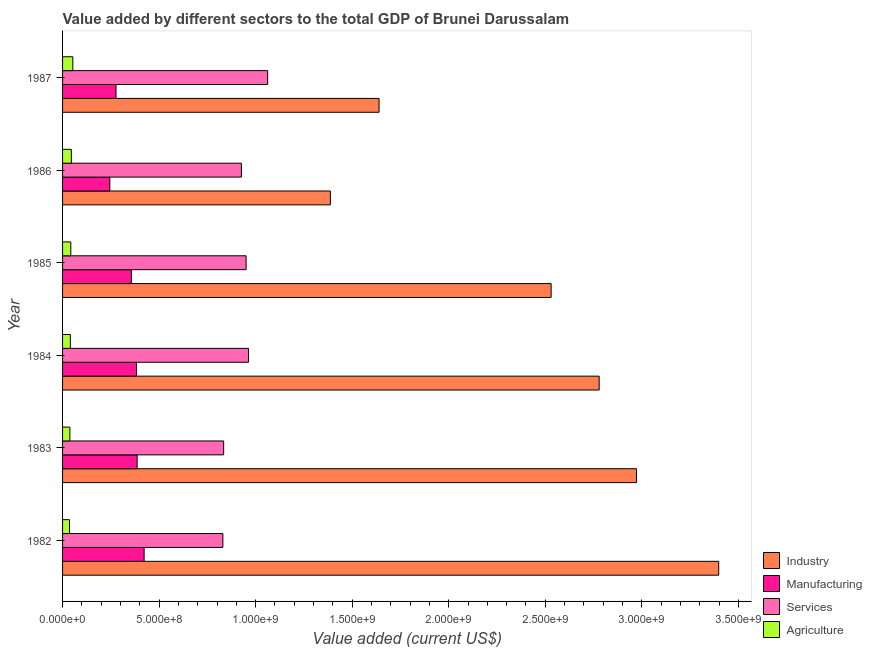How many groups of bars are there?
Your answer should be compact. 6. Are the number of bars on each tick of the Y-axis equal?
Offer a terse response. Yes. How many bars are there on the 6th tick from the top?
Keep it short and to the point. 4. What is the value added by agricultural sector in 1986?
Keep it short and to the point. 4.55e+07. Across all years, what is the maximum value added by industrial sector?
Ensure brevity in your answer.  3.40e+09. Across all years, what is the minimum value added by services sector?
Offer a terse response. 8.30e+08. In which year was the value added by manufacturing sector maximum?
Offer a very short reply. 1982. What is the total value added by agricultural sector in the graph?
Provide a succinct answer. 2.56e+08. What is the difference between the value added by industrial sector in 1983 and that in 1985?
Provide a short and direct response. 4.42e+08. What is the difference between the value added by industrial sector in 1982 and the value added by manufacturing sector in 1986?
Keep it short and to the point. 3.15e+09. What is the average value added by manufacturing sector per year?
Make the answer very short. 3.45e+08. In the year 1984, what is the difference between the value added by services sector and value added by industrial sector?
Make the answer very short. -1.82e+09. What is the ratio of the value added by agricultural sector in 1983 to that in 1984?
Your answer should be compact. 0.94. What is the difference between the highest and the second highest value added by agricultural sector?
Offer a very short reply. 7.71e+06. What is the difference between the highest and the lowest value added by agricultural sector?
Keep it short and to the point. 1.72e+07. What does the 3rd bar from the top in 1983 represents?
Your answer should be compact. Manufacturing. What does the 2nd bar from the bottom in 1984 represents?
Offer a terse response. Manufacturing. Are all the bars in the graph horizontal?
Offer a terse response. Yes. What is the difference between two consecutive major ticks on the X-axis?
Make the answer very short. 5.00e+08. What is the title of the graph?
Make the answer very short. Value added by different sectors to the total GDP of Brunei Darussalam. What is the label or title of the X-axis?
Make the answer very short. Value added (current US$). What is the label or title of the Y-axis?
Your response must be concise. Year. What is the Value added (current US$) in Industry in 1982?
Keep it short and to the point. 3.40e+09. What is the Value added (current US$) in Manufacturing in 1982?
Your answer should be very brief. 4.22e+08. What is the Value added (current US$) of Services in 1982?
Offer a terse response. 8.30e+08. What is the Value added (current US$) in Agriculture in 1982?
Offer a terse response. 3.60e+07. What is the Value added (current US$) of Industry in 1983?
Your answer should be compact. 2.97e+09. What is the Value added (current US$) in Manufacturing in 1983?
Keep it short and to the point. 3.86e+08. What is the Value added (current US$) of Services in 1983?
Your answer should be compact. 8.34e+08. What is the Value added (current US$) of Agriculture in 1983?
Your answer should be compact. 3.79e+07. What is the Value added (current US$) of Industry in 1984?
Make the answer very short. 2.78e+09. What is the Value added (current US$) of Manufacturing in 1984?
Provide a short and direct response. 3.83e+08. What is the Value added (current US$) in Services in 1984?
Provide a succinct answer. 9.63e+08. What is the Value added (current US$) of Agriculture in 1984?
Provide a short and direct response. 4.03e+07. What is the Value added (current US$) of Industry in 1985?
Your response must be concise. 2.53e+09. What is the Value added (current US$) in Manufacturing in 1985?
Ensure brevity in your answer.  3.56e+08. What is the Value added (current US$) of Services in 1985?
Provide a succinct answer. 9.51e+08. What is the Value added (current US$) in Agriculture in 1985?
Make the answer very short. 4.27e+07. What is the Value added (current US$) in Industry in 1986?
Your response must be concise. 1.39e+09. What is the Value added (current US$) of Manufacturing in 1986?
Offer a terse response. 2.45e+08. What is the Value added (current US$) of Services in 1986?
Provide a succinct answer. 9.26e+08. What is the Value added (current US$) in Agriculture in 1986?
Keep it short and to the point. 4.55e+07. What is the Value added (current US$) of Industry in 1987?
Give a very brief answer. 1.64e+09. What is the Value added (current US$) in Manufacturing in 1987?
Your answer should be compact. 2.77e+08. What is the Value added (current US$) of Services in 1987?
Offer a very short reply. 1.06e+09. What is the Value added (current US$) in Agriculture in 1987?
Offer a terse response. 5.32e+07. Across all years, what is the maximum Value added (current US$) of Industry?
Give a very brief answer. 3.40e+09. Across all years, what is the maximum Value added (current US$) in Manufacturing?
Provide a short and direct response. 4.22e+08. Across all years, what is the maximum Value added (current US$) in Services?
Keep it short and to the point. 1.06e+09. Across all years, what is the maximum Value added (current US$) in Agriculture?
Offer a terse response. 5.32e+07. Across all years, what is the minimum Value added (current US$) of Industry?
Make the answer very short. 1.39e+09. Across all years, what is the minimum Value added (current US$) of Manufacturing?
Provide a short and direct response. 2.45e+08. Across all years, what is the minimum Value added (current US$) in Services?
Offer a very short reply. 8.30e+08. Across all years, what is the minimum Value added (current US$) in Agriculture?
Provide a short and direct response. 3.60e+07. What is the total Value added (current US$) in Industry in the graph?
Offer a terse response. 1.47e+1. What is the total Value added (current US$) of Manufacturing in the graph?
Your answer should be compact. 2.07e+09. What is the total Value added (current US$) of Services in the graph?
Offer a terse response. 5.57e+09. What is the total Value added (current US$) in Agriculture in the graph?
Provide a short and direct response. 2.56e+08. What is the difference between the Value added (current US$) in Industry in 1982 and that in 1983?
Make the answer very short. 4.26e+08. What is the difference between the Value added (current US$) in Manufacturing in 1982 and that in 1983?
Your response must be concise. 3.62e+07. What is the difference between the Value added (current US$) of Services in 1982 and that in 1983?
Your answer should be very brief. -4.17e+06. What is the difference between the Value added (current US$) in Agriculture in 1982 and that in 1983?
Your answer should be very brief. -1.88e+06. What is the difference between the Value added (current US$) of Industry in 1982 and that in 1984?
Provide a short and direct response. 6.19e+08. What is the difference between the Value added (current US$) in Manufacturing in 1982 and that in 1984?
Your answer should be very brief. 3.94e+07. What is the difference between the Value added (current US$) in Services in 1982 and that in 1984?
Provide a succinct answer. -1.33e+08. What is the difference between the Value added (current US$) in Agriculture in 1982 and that in 1984?
Your answer should be compact. -4.34e+06. What is the difference between the Value added (current US$) in Industry in 1982 and that in 1985?
Ensure brevity in your answer.  8.68e+08. What is the difference between the Value added (current US$) in Manufacturing in 1982 and that in 1985?
Offer a terse response. 6.61e+07. What is the difference between the Value added (current US$) in Services in 1982 and that in 1985?
Make the answer very short. -1.20e+08. What is the difference between the Value added (current US$) of Agriculture in 1982 and that in 1985?
Offer a terse response. -6.74e+06. What is the difference between the Value added (current US$) of Industry in 1982 and that in 1986?
Provide a succinct answer. 2.01e+09. What is the difference between the Value added (current US$) in Manufacturing in 1982 and that in 1986?
Provide a succinct answer. 1.78e+08. What is the difference between the Value added (current US$) in Services in 1982 and that in 1986?
Your answer should be very brief. -9.60e+07. What is the difference between the Value added (current US$) of Agriculture in 1982 and that in 1986?
Ensure brevity in your answer.  -9.49e+06. What is the difference between the Value added (current US$) of Industry in 1982 and that in 1987?
Your answer should be compact. 1.76e+09. What is the difference between the Value added (current US$) in Manufacturing in 1982 and that in 1987?
Your response must be concise. 1.46e+08. What is the difference between the Value added (current US$) of Services in 1982 and that in 1987?
Your answer should be very brief. -2.32e+08. What is the difference between the Value added (current US$) of Agriculture in 1982 and that in 1987?
Give a very brief answer. -1.72e+07. What is the difference between the Value added (current US$) in Industry in 1983 and that in 1984?
Provide a succinct answer. 1.93e+08. What is the difference between the Value added (current US$) in Manufacturing in 1983 and that in 1984?
Give a very brief answer. 3.17e+06. What is the difference between the Value added (current US$) in Services in 1983 and that in 1984?
Make the answer very short. -1.29e+08. What is the difference between the Value added (current US$) of Agriculture in 1983 and that in 1984?
Ensure brevity in your answer.  -2.46e+06. What is the difference between the Value added (current US$) of Industry in 1983 and that in 1985?
Make the answer very short. 4.42e+08. What is the difference between the Value added (current US$) in Manufacturing in 1983 and that in 1985?
Make the answer very short. 2.98e+07. What is the difference between the Value added (current US$) in Services in 1983 and that in 1985?
Provide a short and direct response. -1.16e+08. What is the difference between the Value added (current US$) in Agriculture in 1983 and that in 1985?
Your answer should be compact. -4.86e+06. What is the difference between the Value added (current US$) of Industry in 1983 and that in 1986?
Ensure brevity in your answer.  1.59e+09. What is the difference between the Value added (current US$) of Manufacturing in 1983 and that in 1986?
Your answer should be compact. 1.41e+08. What is the difference between the Value added (current US$) of Services in 1983 and that in 1986?
Your answer should be very brief. -9.18e+07. What is the difference between the Value added (current US$) of Agriculture in 1983 and that in 1986?
Make the answer very short. -7.61e+06. What is the difference between the Value added (current US$) of Industry in 1983 and that in 1987?
Give a very brief answer. 1.33e+09. What is the difference between the Value added (current US$) in Manufacturing in 1983 and that in 1987?
Offer a terse response. 1.09e+08. What is the difference between the Value added (current US$) in Services in 1983 and that in 1987?
Your response must be concise. -2.28e+08. What is the difference between the Value added (current US$) of Agriculture in 1983 and that in 1987?
Provide a succinct answer. -1.53e+07. What is the difference between the Value added (current US$) in Industry in 1984 and that in 1985?
Make the answer very short. 2.49e+08. What is the difference between the Value added (current US$) in Manufacturing in 1984 and that in 1985?
Offer a very short reply. 2.67e+07. What is the difference between the Value added (current US$) of Services in 1984 and that in 1985?
Keep it short and to the point. 1.26e+07. What is the difference between the Value added (current US$) of Agriculture in 1984 and that in 1985?
Provide a short and direct response. -2.41e+06. What is the difference between the Value added (current US$) of Industry in 1984 and that in 1986?
Make the answer very short. 1.39e+09. What is the difference between the Value added (current US$) in Manufacturing in 1984 and that in 1986?
Keep it short and to the point. 1.38e+08. What is the difference between the Value added (current US$) in Services in 1984 and that in 1986?
Give a very brief answer. 3.70e+07. What is the difference between the Value added (current US$) of Agriculture in 1984 and that in 1986?
Provide a succinct answer. -5.15e+06. What is the difference between the Value added (current US$) of Industry in 1984 and that in 1987?
Keep it short and to the point. 1.14e+09. What is the difference between the Value added (current US$) in Manufacturing in 1984 and that in 1987?
Keep it short and to the point. 1.06e+08. What is the difference between the Value added (current US$) of Services in 1984 and that in 1987?
Make the answer very short. -9.90e+07. What is the difference between the Value added (current US$) of Agriculture in 1984 and that in 1987?
Your answer should be very brief. -1.29e+07. What is the difference between the Value added (current US$) in Industry in 1985 and that in 1986?
Provide a short and direct response. 1.14e+09. What is the difference between the Value added (current US$) of Manufacturing in 1985 and that in 1986?
Your answer should be very brief. 1.12e+08. What is the difference between the Value added (current US$) in Services in 1985 and that in 1986?
Keep it short and to the point. 2.44e+07. What is the difference between the Value added (current US$) in Agriculture in 1985 and that in 1986?
Provide a short and direct response. -2.74e+06. What is the difference between the Value added (current US$) in Industry in 1985 and that in 1987?
Ensure brevity in your answer.  8.91e+08. What is the difference between the Value added (current US$) of Manufacturing in 1985 and that in 1987?
Keep it short and to the point. 7.95e+07. What is the difference between the Value added (current US$) in Services in 1985 and that in 1987?
Ensure brevity in your answer.  -1.12e+08. What is the difference between the Value added (current US$) of Agriculture in 1985 and that in 1987?
Make the answer very short. -1.05e+07. What is the difference between the Value added (current US$) of Industry in 1986 and that in 1987?
Make the answer very short. -2.52e+08. What is the difference between the Value added (current US$) in Manufacturing in 1986 and that in 1987?
Provide a short and direct response. -3.20e+07. What is the difference between the Value added (current US$) of Services in 1986 and that in 1987?
Your response must be concise. -1.36e+08. What is the difference between the Value added (current US$) in Agriculture in 1986 and that in 1987?
Make the answer very short. -7.71e+06. What is the difference between the Value added (current US$) in Industry in 1982 and the Value added (current US$) in Manufacturing in 1983?
Keep it short and to the point. 3.01e+09. What is the difference between the Value added (current US$) of Industry in 1982 and the Value added (current US$) of Services in 1983?
Provide a short and direct response. 2.56e+09. What is the difference between the Value added (current US$) of Industry in 1982 and the Value added (current US$) of Agriculture in 1983?
Provide a succinct answer. 3.36e+09. What is the difference between the Value added (current US$) in Manufacturing in 1982 and the Value added (current US$) in Services in 1983?
Provide a succinct answer. -4.12e+08. What is the difference between the Value added (current US$) in Manufacturing in 1982 and the Value added (current US$) in Agriculture in 1983?
Provide a short and direct response. 3.85e+08. What is the difference between the Value added (current US$) in Services in 1982 and the Value added (current US$) in Agriculture in 1983?
Make the answer very short. 7.92e+08. What is the difference between the Value added (current US$) in Industry in 1982 and the Value added (current US$) in Manufacturing in 1984?
Make the answer very short. 3.02e+09. What is the difference between the Value added (current US$) in Industry in 1982 and the Value added (current US$) in Services in 1984?
Make the answer very short. 2.43e+09. What is the difference between the Value added (current US$) in Industry in 1982 and the Value added (current US$) in Agriculture in 1984?
Offer a terse response. 3.36e+09. What is the difference between the Value added (current US$) in Manufacturing in 1982 and the Value added (current US$) in Services in 1984?
Your answer should be very brief. -5.41e+08. What is the difference between the Value added (current US$) in Manufacturing in 1982 and the Value added (current US$) in Agriculture in 1984?
Provide a short and direct response. 3.82e+08. What is the difference between the Value added (current US$) of Services in 1982 and the Value added (current US$) of Agriculture in 1984?
Your answer should be compact. 7.90e+08. What is the difference between the Value added (current US$) of Industry in 1982 and the Value added (current US$) of Manufacturing in 1985?
Your answer should be very brief. 3.04e+09. What is the difference between the Value added (current US$) of Industry in 1982 and the Value added (current US$) of Services in 1985?
Make the answer very short. 2.45e+09. What is the difference between the Value added (current US$) of Industry in 1982 and the Value added (current US$) of Agriculture in 1985?
Offer a very short reply. 3.36e+09. What is the difference between the Value added (current US$) of Manufacturing in 1982 and the Value added (current US$) of Services in 1985?
Your answer should be compact. -5.28e+08. What is the difference between the Value added (current US$) in Manufacturing in 1982 and the Value added (current US$) in Agriculture in 1985?
Offer a very short reply. 3.80e+08. What is the difference between the Value added (current US$) in Services in 1982 and the Value added (current US$) in Agriculture in 1985?
Keep it short and to the point. 7.87e+08. What is the difference between the Value added (current US$) in Industry in 1982 and the Value added (current US$) in Manufacturing in 1986?
Give a very brief answer. 3.15e+09. What is the difference between the Value added (current US$) in Industry in 1982 and the Value added (current US$) in Services in 1986?
Your answer should be very brief. 2.47e+09. What is the difference between the Value added (current US$) in Industry in 1982 and the Value added (current US$) in Agriculture in 1986?
Give a very brief answer. 3.35e+09. What is the difference between the Value added (current US$) of Manufacturing in 1982 and the Value added (current US$) of Services in 1986?
Give a very brief answer. -5.04e+08. What is the difference between the Value added (current US$) of Manufacturing in 1982 and the Value added (current US$) of Agriculture in 1986?
Provide a succinct answer. 3.77e+08. What is the difference between the Value added (current US$) of Services in 1982 and the Value added (current US$) of Agriculture in 1986?
Make the answer very short. 7.85e+08. What is the difference between the Value added (current US$) of Industry in 1982 and the Value added (current US$) of Manufacturing in 1987?
Offer a terse response. 3.12e+09. What is the difference between the Value added (current US$) in Industry in 1982 and the Value added (current US$) in Services in 1987?
Your answer should be very brief. 2.34e+09. What is the difference between the Value added (current US$) of Industry in 1982 and the Value added (current US$) of Agriculture in 1987?
Provide a short and direct response. 3.34e+09. What is the difference between the Value added (current US$) in Manufacturing in 1982 and the Value added (current US$) in Services in 1987?
Make the answer very short. -6.40e+08. What is the difference between the Value added (current US$) of Manufacturing in 1982 and the Value added (current US$) of Agriculture in 1987?
Your response must be concise. 3.69e+08. What is the difference between the Value added (current US$) of Services in 1982 and the Value added (current US$) of Agriculture in 1987?
Give a very brief answer. 7.77e+08. What is the difference between the Value added (current US$) in Industry in 1983 and the Value added (current US$) in Manufacturing in 1984?
Make the answer very short. 2.59e+09. What is the difference between the Value added (current US$) of Industry in 1983 and the Value added (current US$) of Services in 1984?
Your answer should be compact. 2.01e+09. What is the difference between the Value added (current US$) of Industry in 1983 and the Value added (current US$) of Agriculture in 1984?
Ensure brevity in your answer.  2.93e+09. What is the difference between the Value added (current US$) in Manufacturing in 1983 and the Value added (current US$) in Services in 1984?
Give a very brief answer. -5.77e+08. What is the difference between the Value added (current US$) of Manufacturing in 1983 and the Value added (current US$) of Agriculture in 1984?
Your response must be concise. 3.46e+08. What is the difference between the Value added (current US$) of Services in 1983 and the Value added (current US$) of Agriculture in 1984?
Make the answer very short. 7.94e+08. What is the difference between the Value added (current US$) in Industry in 1983 and the Value added (current US$) in Manufacturing in 1985?
Offer a terse response. 2.62e+09. What is the difference between the Value added (current US$) of Industry in 1983 and the Value added (current US$) of Services in 1985?
Give a very brief answer. 2.02e+09. What is the difference between the Value added (current US$) in Industry in 1983 and the Value added (current US$) in Agriculture in 1985?
Provide a short and direct response. 2.93e+09. What is the difference between the Value added (current US$) in Manufacturing in 1983 and the Value added (current US$) in Services in 1985?
Provide a succinct answer. -5.64e+08. What is the difference between the Value added (current US$) in Manufacturing in 1983 and the Value added (current US$) in Agriculture in 1985?
Your answer should be very brief. 3.43e+08. What is the difference between the Value added (current US$) in Services in 1983 and the Value added (current US$) in Agriculture in 1985?
Make the answer very short. 7.92e+08. What is the difference between the Value added (current US$) in Industry in 1983 and the Value added (current US$) in Manufacturing in 1986?
Provide a short and direct response. 2.73e+09. What is the difference between the Value added (current US$) in Industry in 1983 and the Value added (current US$) in Services in 1986?
Offer a very short reply. 2.05e+09. What is the difference between the Value added (current US$) of Industry in 1983 and the Value added (current US$) of Agriculture in 1986?
Make the answer very short. 2.93e+09. What is the difference between the Value added (current US$) of Manufacturing in 1983 and the Value added (current US$) of Services in 1986?
Give a very brief answer. -5.40e+08. What is the difference between the Value added (current US$) of Manufacturing in 1983 and the Value added (current US$) of Agriculture in 1986?
Your answer should be very brief. 3.41e+08. What is the difference between the Value added (current US$) in Services in 1983 and the Value added (current US$) in Agriculture in 1986?
Provide a short and direct response. 7.89e+08. What is the difference between the Value added (current US$) of Industry in 1983 and the Value added (current US$) of Manufacturing in 1987?
Offer a very short reply. 2.70e+09. What is the difference between the Value added (current US$) of Industry in 1983 and the Value added (current US$) of Services in 1987?
Offer a terse response. 1.91e+09. What is the difference between the Value added (current US$) of Industry in 1983 and the Value added (current US$) of Agriculture in 1987?
Provide a succinct answer. 2.92e+09. What is the difference between the Value added (current US$) of Manufacturing in 1983 and the Value added (current US$) of Services in 1987?
Your answer should be compact. -6.76e+08. What is the difference between the Value added (current US$) in Manufacturing in 1983 and the Value added (current US$) in Agriculture in 1987?
Make the answer very short. 3.33e+08. What is the difference between the Value added (current US$) in Services in 1983 and the Value added (current US$) in Agriculture in 1987?
Offer a very short reply. 7.81e+08. What is the difference between the Value added (current US$) of Industry in 1984 and the Value added (current US$) of Manufacturing in 1985?
Provide a short and direct response. 2.42e+09. What is the difference between the Value added (current US$) in Industry in 1984 and the Value added (current US$) in Services in 1985?
Give a very brief answer. 1.83e+09. What is the difference between the Value added (current US$) of Industry in 1984 and the Value added (current US$) of Agriculture in 1985?
Provide a succinct answer. 2.74e+09. What is the difference between the Value added (current US$) of Manufacturing in 1984 and the Value added (current US$) of Services in 1985?
Give a very brief answer. -5.68e+08. What is the difference between the Value added (current US$) in Manufacturing in 1984 and the Value added (current US$) in Agriculture in 1985?
Keep it short and to the point. 3.40e+08. What is the difference between the Value added (current US$) of Services in 1984 and the Value added (current US$) of Agriculture in 1985?
Your answer should be very brief. 9.20e+08. What is the difference between the Value added (current US$) in Industry in 1984 and the Value added (current US$) in Manufacturing in 1986?
Ensure brevity in your answer.  2.53e+09. What is the difference between the Value added (current US$) in Industry in 1984 and the Value added (current US$) in Services in 1986?
Ensure brevity in your answer.  1.85e+09. What is the difference between the Value added (current US$) in Industry in 1984 and the Value added (current US$) in Agriculture in 1986?
Give a very brief answer. 2.73e+09. What is the difference between the Value added (current US$) of Manufacturing in 1984 and the Value added (current US$) of Services in 1986?
Your answer should be very brief. -5.43e+08. What is the difference between the Value added (current US$) in Manufacturing in 1984 and the Value added (current US$) in Agriculture in 1986?
Provide a succinct answer. 3.38e+08. What is the difference between the Value added (current US$) of Services in 1984 and the Value added (current US$) of Agriculture in 1986?
Provide a succinct answer. 9.18e+08. What is the difference between the Value added (current US$) of Industry in 1984 and the Value added (current US$) of Manufacturing in 1987?
Your answer should be very brief. 2.50e+09. What is the difference between the Value added (current US$) in Industry in 1984 and the Value added (current US$) in Services in 1987?
Your answer should be very brief. 1.72e+09. What is the difference between the Value added (current US$) in Industry in 1984 and the Value added (current US$) in Agriculture in 1987?
Provide a short and direct response. 2.73e+09. What is the difference between the Value added (current US$) in Manufacturing in 1984 and the Value added (current US$) in Services in 1987?
Ensure brevity in your answer.  -6.79e+08. What is the difference between the Value added (current US$) of Manufacturing in 1984 and the Value added (current US$) of Agriculture in 1987?
Provide a short and direct response. 3.30e+08. What is the difference between the Value added (current US$) in Services in 1984 and the Value added (current US$) in Agriculture in 1987?
Your response must be concise. 9.10e+08. What is the difference between the Value added (current US$) in Industry in 1985 and the Value added (current US$) in Manufacturing in 1986?
Give a very brief answer. 2.29e+09. What is the difference between the Value added (current US$) in Industry in 1985 and the Value added (current US$) in Services in 1986?
Make the answer very short. 1.60e+09. What is the difference between the Value added (current US$) in Industry in 1985 and the Value added (current US$) in Agriculture in 1986?
Provide a succinct answer. 2.48e+09. What is the difference between the Value added (current US$) of Manufacturing in 1985 and the Value added (current US$) of Services in 1986?
Your answer should be very brief. -5.70e+08. What is the difference between the Value added (current US$) in Manufacturing in 1985 and the Value added (current US$) in Agriculture in 1986?
Provide a short and direct response. 3.11e+08. What is the difference between the Value added (current US$) of Services in 1985 and the Value added (current US$) of Agriculture in 1986?
Ensure brevity in your answer.  9.05e+08. What is the difference between the Value added (current US$) in Industry in 1985 and the Value added (current US$) in Manufacturing in 1987?
Keep it short and to the point. 2.25e+09. What is the difference between the Value added (current US$) of Industry in 1985 and the Value added (current US$) of Services in 1987?
Offer a very short reply. 1.47e+09. What is the difference between the Value added (current US$) in Industry in 1985 and the Value added (current US$) in Agriculture in 1987?
Your response must be concise. 2.48e+09. What is the difference between the Value added (current US$) in Manufacturing in 1985 and the Value added (current US$) in Services in 1987?
Your response must be concise. -7.06e+08. What is the difference between the Value added (current US$) in Manufacturing in 1985 and the Value added (current US$) in Agriculture in 1987?
Offer a terse response. 3.03e+08. What is the difference between the Value added (current US$) of Services in 1985 and the Value added (current US$) of Agriculture in 1987?
Provide a short and direct response. 8.97e+08. What is the difference between the Value added (current US$) in Industry in 1986 and the Value added (current US$) in Manufacturing in 1987?
Your answer should be compact. 1.11e+09. What is the difference between the Value added (current US$) of Industry in 1986 and the Value added (current US$) of Services in 1987?
Your answer should be very brief. 3.25e+08. What is the difference between the Value added (current US$) in Industry in 1986 and the Value added (current US$) in Agriculture in 1987?
Your response must be concise. 1.33e+09. What is the difference between the Value added (current US$) of Manufacturing in 1986 and the Value added (current US$) of Services in 1987?
Offer a terse response. -8.17e+08. What is the difference between the Value added (current US$) in Manufacturing in 1986 and the Value added (current US$) in Agriculture in 1987?
Offer a terse response. 1.92e+08. What is the difference between the Value added (current US$) of Services in 1986 and the Value added (current US$) of Agriculture in 1987?
Offer a very short reply. 8.73e+08. What is the average Value added (current US$) in Industry per year?
Your answer should be very brief. 2.45e+09. What is the average Value added (current US$) in Manufacturing per year?
Your response must be concise. 3.45e+08. What is the average Value added (current US$) of Services per year?
Make the answer very short. 9.28e+08. What is the average Value added (current US$) of Agriculture per year?
Give a very brief answer. 4.26e+07. In the year 1982, what is the difference between the Value added (current US$) of Industry and Value added (current US$) of Manufacturing?
Keep it short and to the point. 2.98e+09. In the year 1982, what is the difference between the Value added (current US$) of Industry and Value added (current US$) of Services?
Give a very brief answer. 2.57e+09. In the year 1982, what is the difference between the Value added (current US$) of Industry and Value added (current US$) of Agriculture?
Your answer should be compact. 3.36e+09. In the year 1982, what is the difference between the Value added (current US$) of Manufacturing and Value added (current US$) of Services?
Provide a short and direct response. -4.08e+08. In the year 1982, what is the difference between the Value added (current US$) in Manufacturing and Value added (current US$) in Agriculture?
Your answer should be very brief. 3.86e+08. In the year 1982, what is the difference between the Value added (current US$) of Services and Value added (current US$) of Agriculture?
Keep it short and to the point. 7.94e+08. In the year 1983, what is the difference between the Value added (current US$) in Industry and Value added (current US$) in Manufacturing?
Offer a terse response. 2.59e+09. In the year 1983, what is the difference between the Value added (current US$) in Industry and Value added (current US$) in Services?
Offer a terse response. 2.14e+09. In the year 1983, what is the difference between the Value added (current US$) in Industry and Value added (current US$) in Agriculture?
Make the answer very short. 2.93e+09. In the year 1983, what is the difference between the Value added (current US$) of Manufacturing and Value added (current US$) of Services?
Offer a very short reply. -4.48e+08. In the year 1983, what is the difference between the Value added (current US$) in Manufacturing and Value added (current US$) in Agriculture?
Your answer should be compact. 3.48e+08. In the year 1983, what is the difference between the Value added (current US$) of Services and Value added (current US$) of Agriculture?
Offer a very short reply. 7.96e+08. In the year 1984, what is the difference between the Value added (current US$) in Industry and Value added (current US$) in Manufacturing?
Your answer should be very brief. 2.40e+09. In the year 1984, what is the difference between the Value added (current US$) of Industry and Value added (current US$) of Services?
Offer a very short reply. 1.82e+09. In the year 1984, what is the difference between the Value added (current US$) of Industry and Value added (current US$) of Agriculture?
Give a very brief answer. 2.74e+09. In the year 1984, what is the difference between the Value added (current US$) in Manufacturing and Value added (current US$) in Services?
Your answer should be very brief. -5.80e+08. In the year 1984, what is the difference between the Value added (current US$) of Manufacturing and Value added (current US$) of Agriculture?
Make the answer very short. 3.43e+08. In the year 1984, what is the difference between the Value added (current US$) of Services and Value added (current US$) of Agriculture?
Your response must be concise. 9.23e+08. In the year 1985, what is the difference between the Value added (current US$) of Industry and Value added (current US$) of Manufacturing?
Your answer should be very brief. 2.17e+09. In the year 1985, what is the difference between the Value added (current US$) in Industry and Value added (current US$) in Services?
Make the answer very short. 1.58e+09. In the year 1985, what is the difference between the Value added (current US$) of Industry and Value added (current US$) of Agriculture?
Offer a terse response. 2.49e+09. In the year 1985, what is the difference between the Value added (current US$) in Manufacturing and Value added (current US$) in Services?
Your response must be concise. -5.94e+08. In the year 1985, what is the difference between the Value added (current US$) of Manufacturing and Value added (current US$) of Agriculture?
Provide a succinct answer. 3.14e+08. In the year 1985, what is the difference between the Value added (current US$) of Services and Value added (current US$) of Agriculture?
Provide a short and direct response. 9.08e+08. In the year 1986, what is the difference between the Value added (current US$) in Industry and Value added (current US$) in Manufacturing?
Your answer should be compact. 1.14e+09. In the year 1986, what is the difference between the Value added (current US$) in Industry and Value added (current US$) in Services?
Make the answer very short. 4.61e+08. In the year 1986, what is the difference between the Value added (current US$) of Industry and Value added (current US$) of Agriculture?
Keep it short and to the point. 1.34e+09. In the year 1986, what is the difference between the Value added (current US$) of Manufacturing and Value added (current US$) of Services?
Ensure brevity in your answer.  -6.81e+08. In the year 1986, what is the difference between the Value added (current US$) of Manufacturing and Value added (current US$) of Agriculture?
Your answer should be very brief. 1.99e+08. In the year 1986, what is the difference between the Value added (current US$) of Services and Value added (current US$) of Agriculture?
Provide a succinct answer. 8.81e+08. In the year 1987, what is the difference between the Value added (current US$) of Industry and Value added (current US$) of Manufacturing?
Your answer should be compact. 1.36e+09. In the year 1987, what is the difference between the Value added (current US$) in Industry and Value added (current US$) in Services?
Ensure brevity in your answer.  5.77e+08. In the year 1987, what is the difference between the Value added (current US$) in Industry and Value added (current US$) in Agriculture?
Ensure brevity in your answer.  1.59e+09. In the year 1987, what is the difference between the Value added (current US$) in Manufacturing and Value added (current US$) in Services?
Offer a terse response. -7.85e+08. In the year 1987, what is the difference between the Value added (current US$) of Manufacturing and Value added (current US$) of Agriculture?
Offer a very short reply. 2.24e+08. In the year 1987, what is the difference between the Value added (current US$) of Services and Value added (current US$) of Agriculture?
Ensure brevity in your answer.  1.01e+09. What is the ratio of the Value added (current US$) of Industry in 1982 to that in 1983?
Give a very brief answer. 1.14. What is the ratio of the Value added (current US$) of Manufacturing in 1982 to that in 1983?
Offer a very short reply. 1.09. What is the ratio of the Value added (current US$) in Agriculture in 1982 to that in 1983?
Make the answer very short. 0.95. What is the ratio of the Value added (current US$) of Industry in 1982 to that in 1984?
Keep it short and to the point. 1.22. What is the ratio of the Value added (current US$) of Manufacturing in 1982 to that in 1984?
Offer a very short reply. 1.1. What is the ratio of the Value added (current US$) of Services in 1982 to that in 1984?
Give a very brief answer. 0.86. What is the ratio of the Value added (current US$) of Agriculture in 1982 to that in 1984?
Provide a short and direct response. 0.89. What is the ratio of the Value added (current US$) in Industry in 1982 to that in 1985?
Provide a succinct answer. 1.34. What is the ratio of the Value added (current US$) of Manufacturing in 1982 to that in 1985?
Keep it short and to the point. 1.19. What is the ratio of the Value added (current US$) of Services in 1982 to that in 1985?
Offer a very short reply. 0.87. What is the ratio of the Value added (current US$) of Agriculture in 1982 to that in 1985?
Give a very brief answer. 0.84. What is the ratio of the Value added (current US$) of Industry in 1982 to that in 1986?
Keep it short and to the point. 2.45. What is the ratio of the Value added (current US$) in Manufacturing in 1982 to that in 1986?
Your answer should be very brief. 1.73. What is the ratio of the Value added (current US$) in Services in 1982 to that in 1986?
Your response must be concise. 0.9. What is the ratio of the Value added (current US$) in Agriculture in 1982 to that in 1986?
Offer a very short reply. 0.79. What is the ratio of the Value added (current US$) in Industry in 1982 to that in 1987?
Make the answer very short. 2.07. What is the ratio of the Value added (current US$) in Manufacturing in 1982 to that in 1987?
Offer a very short reply. 1.53. What is the ratio of the Value added (current US$) of Services in 1982 to that in 1987?
Keep it short and to the point. 0.78. What is the ratio of the Value added (current US$) of Agriculture in 1982 to that in 1987?
Offer a terse response. 0.68. What is the ratio of the Value added (current US$) in Industry in 1983 to that in 1984?
Your answer should be compact. 1.07. What is the ratio of the Value added (current US$) in Manufacturing in 1983 to that in 1984?
Your answer should be compact. 1.01. What is the ratio of the Value added (current US$) in Services in 1983 to that in 1984?
Provide a short and direct response. 0.87. What is the ratio of the Value added (current US$) in Agriculture in 1983 to that in 1984?
Give a very brief answer. 0.94. What is the ratio of the Value added (current US$) in Industry in 1983 to that in 1985?
Provide a succinct answer. 1.17. What is the ratio of the Value added (current US$) of Manufacturing in 1983 to that in 1985?
Your answer should be very brief. 1.08. What is the ratio of the Value added (current US$) of Services in 1983 to that in 1985?
Offer a terse response. 0.88. What is the ratio of the Value added (current US$) in Agriculture in 1983 to that in 1985?
Your answer should be compact. 0.89. What is the ratio of the Value added (current US$) of Industry in 1983 to that in 1986?
Offer a terse response. 2.14. What is the ratio of the Value added (current US$) in Manufacturing in 1983 to that in 1986?
Your response must be concise. 1.58. What is the ratio of the Value added (current US$) in Services in 1983 to that in 1986?
Give a very brief answer. 0.9. What is the ratio of the Value added (current US$) of Agriculture in 1983 to that in 1986?
Your response must be concise. 0.83. What is the ratio of the Value added (current US$) of Industry in 1983 to that in 1987?
Provide a short and direct response. 1.81. What is the ratio of the Value added (current US$) of Manufacturing in 1983 to that in 1987?
Offer a very short reply. 1.4. What is the ratio of the Value added (current US$) in Services in 1983 to that in 1987?
Offer a terse response. 0.79. What is the ratio of the Value added (current US$) in Agriculture in 1983 to that in 1987?
Make the answer very short. 0.71. What is the ratio of the Value added (current US$) of Industry in 1984 to that in 1985?
Your answer should be compact. 1.1. What is the ratio of the Value added (current US$) of Manufacturing in 1984 to that in 1985?
Ensure brevity in your answer.  1.07. What is the ratio of the Value added (current US$) of Services in 1984 to that in 1985?
Keep it short and to the point. 1.01. What is the ratio of the Value added (current US$) in Agriculture in 1984 to that in 1985?
Offer a very short reply. 0.94. What is the ratio of the Value added (current US$) in Industry in 1984 to that in 1986?
Your answer should be very brief. 2. What is the ratio of the Value added (current US$) in Manufacturing in 1984 to that in 1986?
Provide a succinct answer. 1.56. What is the ratio of the Value added (current US$) in Services in 1984 to that in 1986?
Make the answer very short. 1.04. What is the ratio of the Value added (current US$) of Agriculture in 1984 to that in 1986?
Provide a short and direct response. 0.89. What is the ratio of the Value added (current US$) of Industry in 1984 to that in 1987?
Offer a terse response. 1.7. What is the ratio of the Value added (current US$) in Manufacturing in 1984 to that in 1987?
Offer a very short reply. 1.38. What is the ratio of the Value added (current US$) in Services in 1984 to that in 1987?
Provide a short and direct response. 0.91. What is the ratio of the Value added (current US$) of Agriculture in 1984 to that in 1987?
Offer a very short reply. 0.76. What is the ratio of the Value added (current US$) in Industry in 1985 to that in 1986?
Your response must be concise. 1.82. What is the ratio of the Value added (current US$) in Manufacturing in 1985 to that in 1986?
Your answer should be very brief. 1.46. What is the ratio of the Value added (current US$) in Services in 1985 to that in 1986?
Provide a short and direct response. 1.03. What is the ratio of the Value added (current US$) of Agriculture in 1985 to that in 1986?
Provide a succinct answer. 0.94. What is the ratio of the Value added (current US$) in Industry in 1985 to that in 1987?
Offer a very short reply. 1.54. What is the ratio of the Value added (current US$) in Manufacturing in 1985 to that in 1987?
Make the answer very short. 1.29. What is the ratio of the Value added (current US$) in Services in 1985 to that in 1987?
Provide a short and direct response. 0.89. What is the ratio of the Value added (current US$) of Agriculture in 1985 to that in 1987?
Make the answer very short. 0.8. What is the ratio of the Value added (current US$) of Industry in 1986 to that in 1987?
Your answer should be very brief. 0.85. What is the ratio of the Value added (current US$) in Manufacturing in 1986 to that in 1987?
Ensure brevity in your answer.  0.88. What is the ratio of the Value added (current US$) in Services in 1986 to that in 1987?
Make the answer very short. 0.87. What is the ratio of the Value added (current US$) of Agriculture in 1986 to that in 1987?
Ensure brevity in your answer.  0.85. What is the difference between the highest and the second highest Value added (current US$) of Industry?
Your answer should be compact. 4.26e+08. What is the difference between the highest and the second highest Value added (current US$) in Manufacturing?
Your response must be concise. 3.62e+07. What is the difference between the highest and the second highest Value added (current US$) in Services?
Give a very brief answer. 9.90e+07. What is the difference between the highest and the second highest Value added (current US$) in Agriculture?
Provide a short and direct response. 7.71e+06. What is the difference between the highest and the lowest Value added (current US$) of Industry?
Offer a very short reply. 2.01e+09. What is the difference between the highest and the lowest Value added (current US$) of Manufacturing?
Ensure brevity in your answer.  1.78e+08. What is the difference between the highest and the lowest Value added (current US$) of Services?
Your answer should be very brief. 2.32e+08. What is the difference between the highest and the lowest Value added (current US$) in Agriculture?
Make the answer very short. 1.72e+07. 